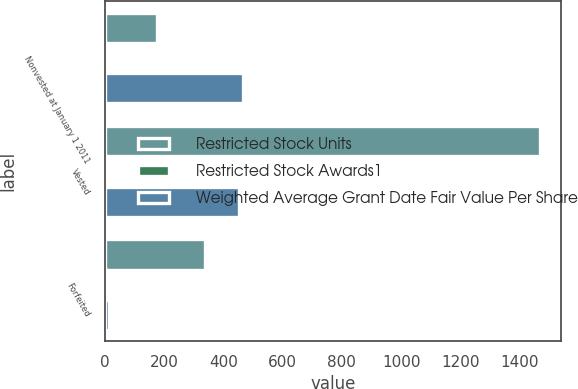Convert chart. <chart><loc_0><loc_0><loc_500><loc_500><stacked_bar_chart><ecel><fcel>Nonvested at January 1 2011<fcel>Vested<fcel>Forfeited<nl><fcel>Restricted Stock Units<fcel>176<fcel>1467<fcel>339<nl><fcel>Restricted Stock Awards1<fcel>5.78<fcel>5.26<fcel>6.29<nl><fcel>Weighted Average Grant Date Fair Value Per Share<fcel>466<fcel>453<fcel>13<nl></chart> 